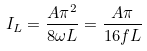Convert formula to latex. <formula><loc_0><loc_0><loc_500><loc_500>I _ { L } = \frac { A \pi ^ { 2 } } { 8 \omega L } = \frac { A \pi } { 1 6 f L }</formula> 